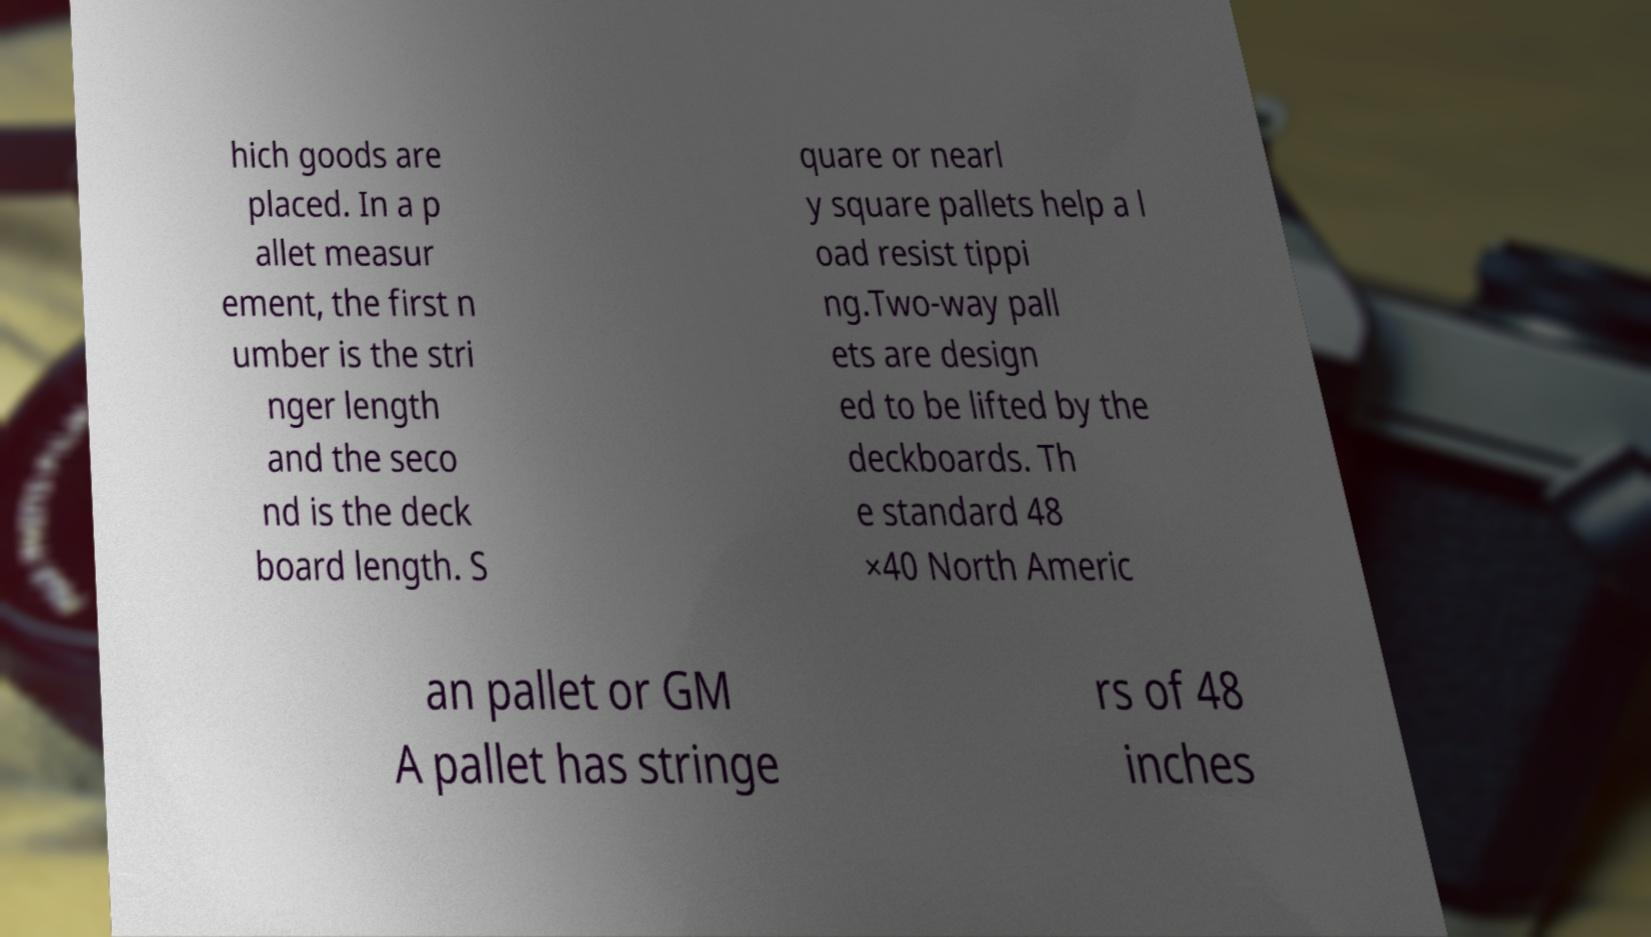Can you accurately transcribe the text from the provided image for me? hich goods are placed. In a p allet measur ement, the first n umber is the stri nger length and the seco nd is the deck board length. S quare or nearl y square pallets help a l oad resist tippi ng.Two-way pall ets are design ed to be lifted by the deckboards. Th e standard 48 ×40 North Americ an pallet or GM A pallet has stringe rs of 48 inches 